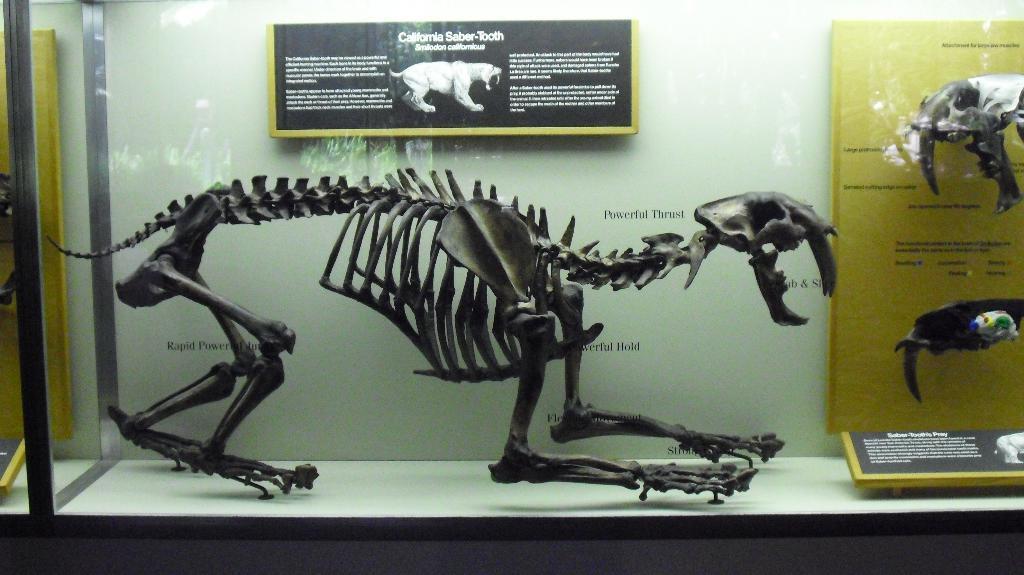Can you describe this image briefly? In the center of the image we can see bones of the animal placed in glass. In the background we can see board and wall. 